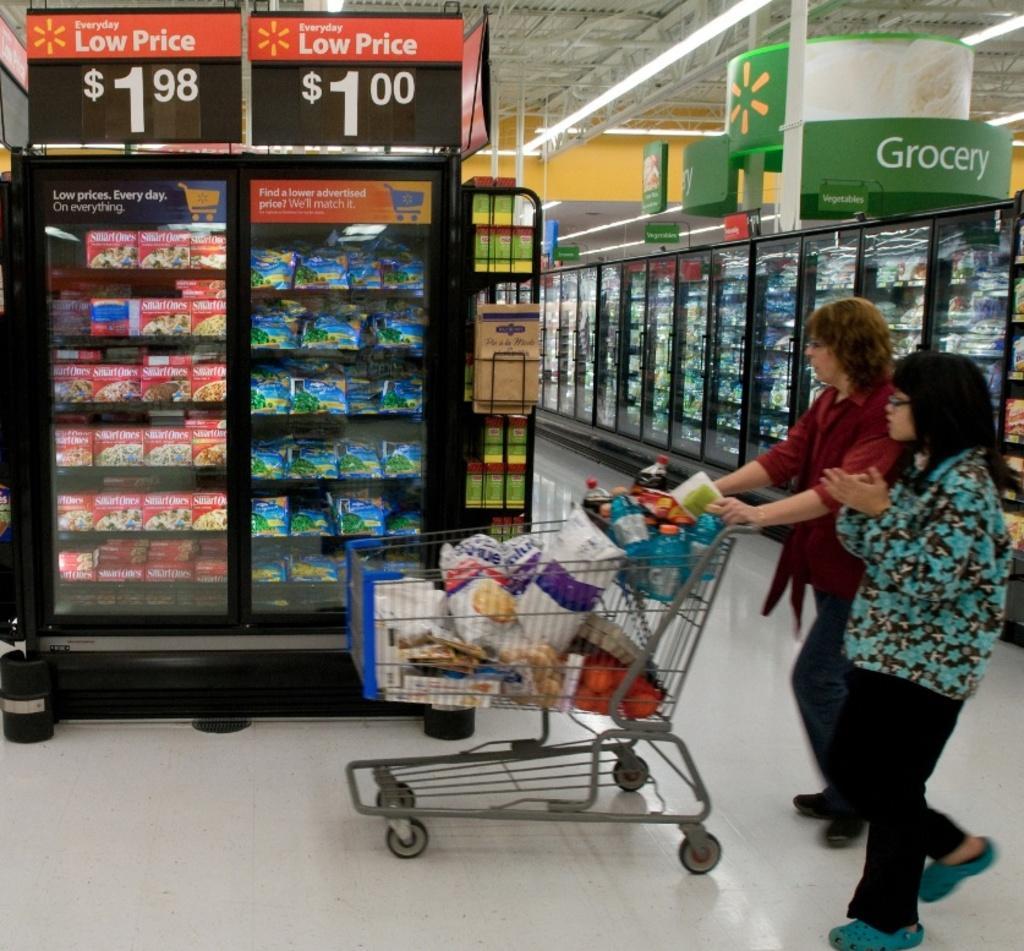In one or two sentences, can you explain what this image depicts? In the picture we can see a supermarket with groceries filled with the racks and some are kept in the glass cupboard and near it, we can see a man and woman walking on the floor holding a cart with some items in it. 